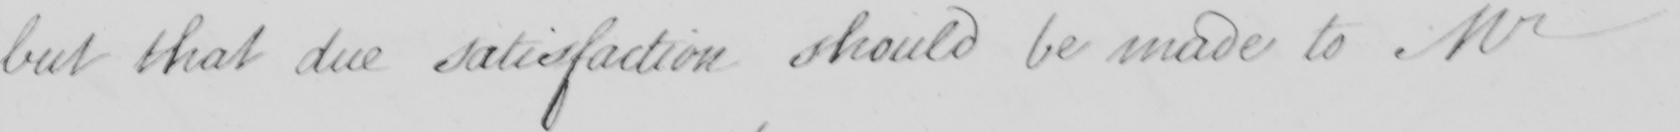Can you read and transcribe this handwriting? but that due satisfaction should be made to Mr 